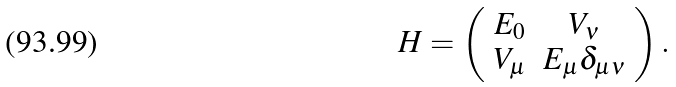<formula> <loc_0><loc_0><loc_500><loc_500>H = \left ( \begin{array} { c c } E _ { 0 } & V _ { \nu } \\ V _ { \mu } & E _ { \mu } \delta _ { \mu \nu } \end{array} \right ) .</formula> 